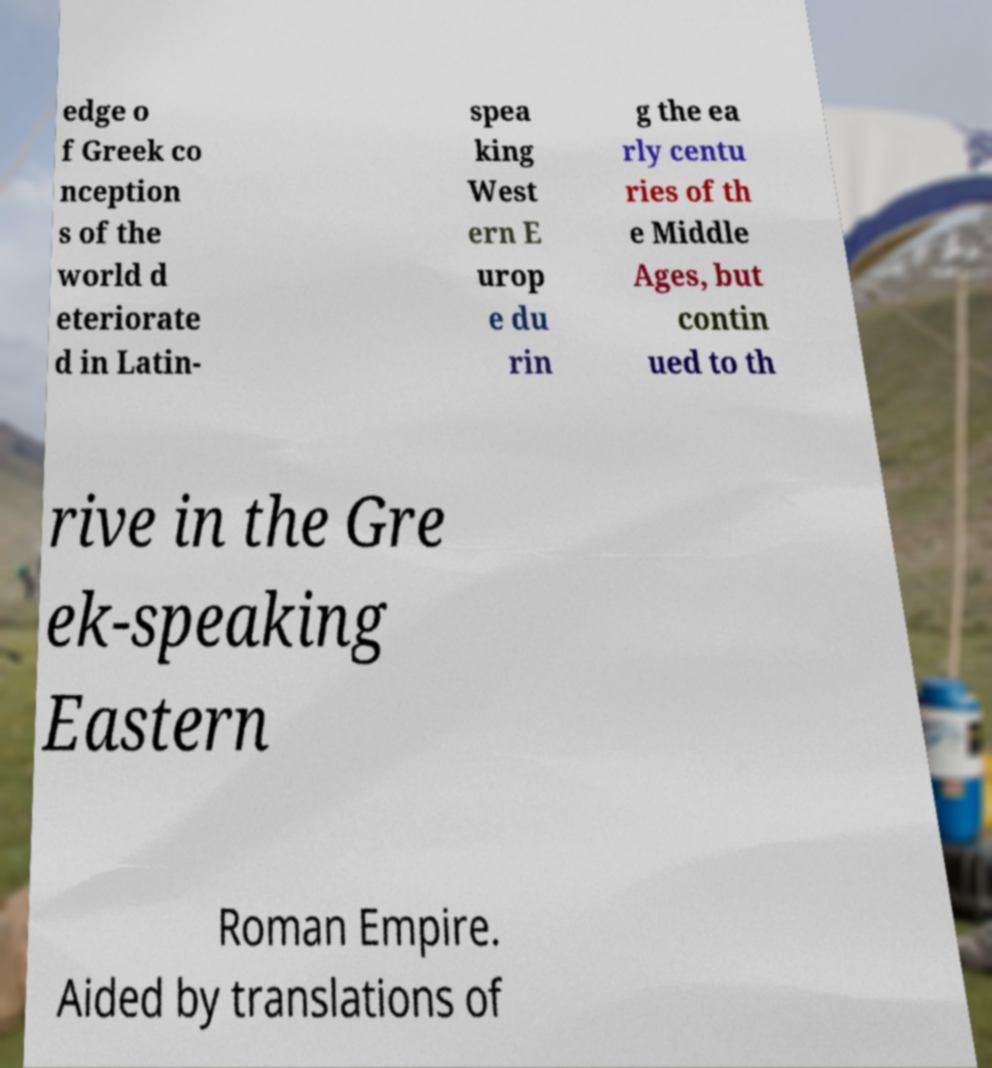Can you accurately transcribe the text from the provided image for me? edge o f Greek co nception s of the world d eteriorate d in Latin- spea king West ern E urop e du rin g the ea rly centu ries of th e Middle Ages, but contin ued to th rive in the Gre ek-speaking Eastern Roman Empire. Aided by translations of 